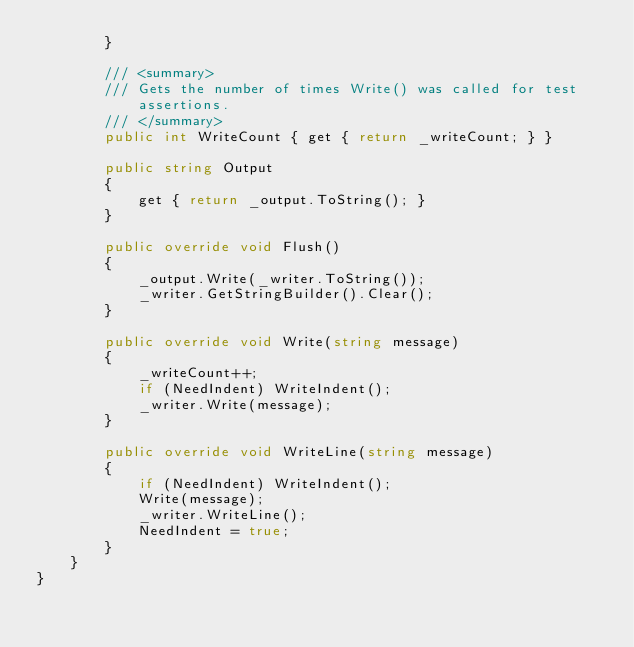Convert code to text. <code><loc_0><loc_0><loc_500><loc_500><_C#_>        }

        /// <summary>
        /// Gets the number of times Write() was called for test assertions.
        /// </summary>
        public int WriteCount { get { return _writeCount; } }

        public string Output
        {
            get { return _output.ToString(); }
        }

        public override void Flush()
        {
            _output.Write(_writer.ToString());
            _writer.GetStringBuilder().Clear();
        }

        public override void Write(string message)
        {
            _writeCount++;
            if (NeedIndent) WriteIndent();
            _writer.Write(message);
        }

        public override void WriteLine(string message)
        {
            if (NeedIndent) WriteIndent();
            Write(message);
            _writer.WriteLine();
            NeedIndent = true;
        }
    }
}
</code> 